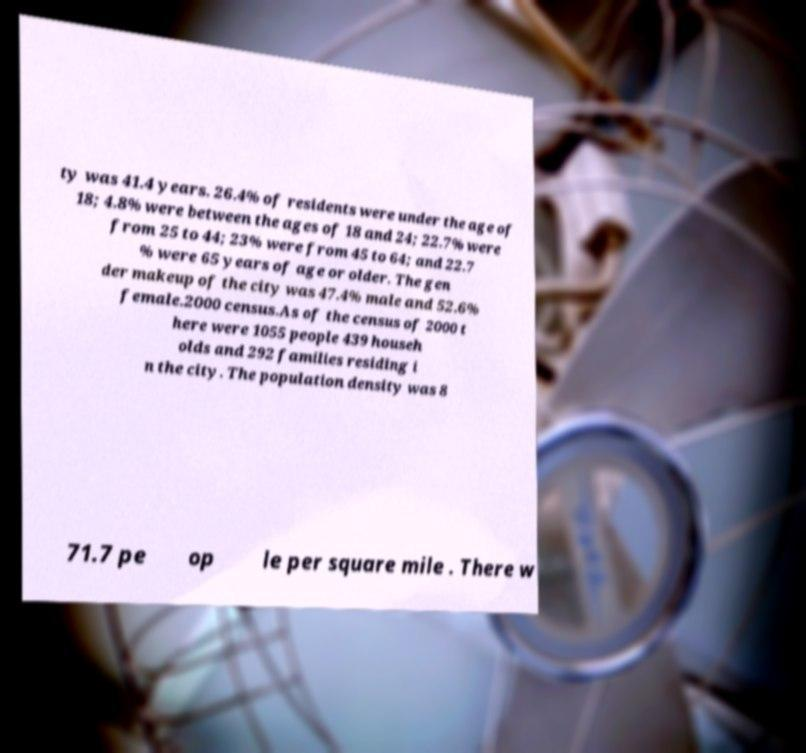What messages or text are displayed in this image? I need them in a readable, typed format. ty was 41.4 years. 26.4% of residents were under the age of 18; 4.8% were between the ages of 18 and 24; 22.7% were from 25 to 44; 23% were from 45 to 64; and 22.7 % were 65 years of age or older. The gen der makeup of the city was 47.4% male and 52.6% female.2000 census.As of the census of 2000 t here were 1055 people 439 househ olds and 292 families residing i n the city. The population density was 8 71.7 pe op le per square mile . There w 